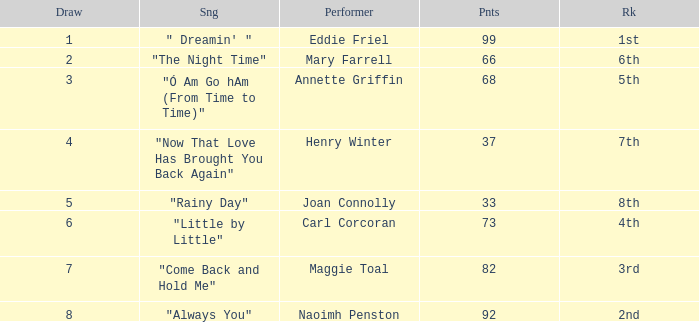Which song has more than 66 points, a draw greater than 3, and is ranked 3rd? "Come Back and Hold Me". 